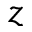<formula> <loc_0><loc_0><loc_500><loc_500>z</formula> 